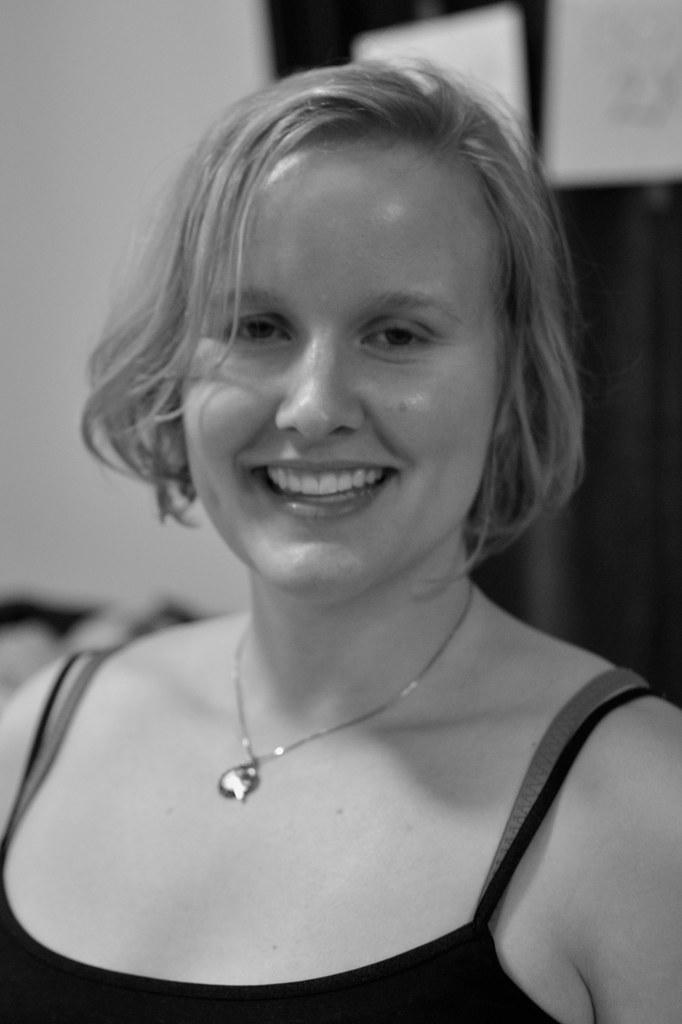Can you describe this image briefly? This image consists of a woman wearing black dress. In the background, there is a wall. 